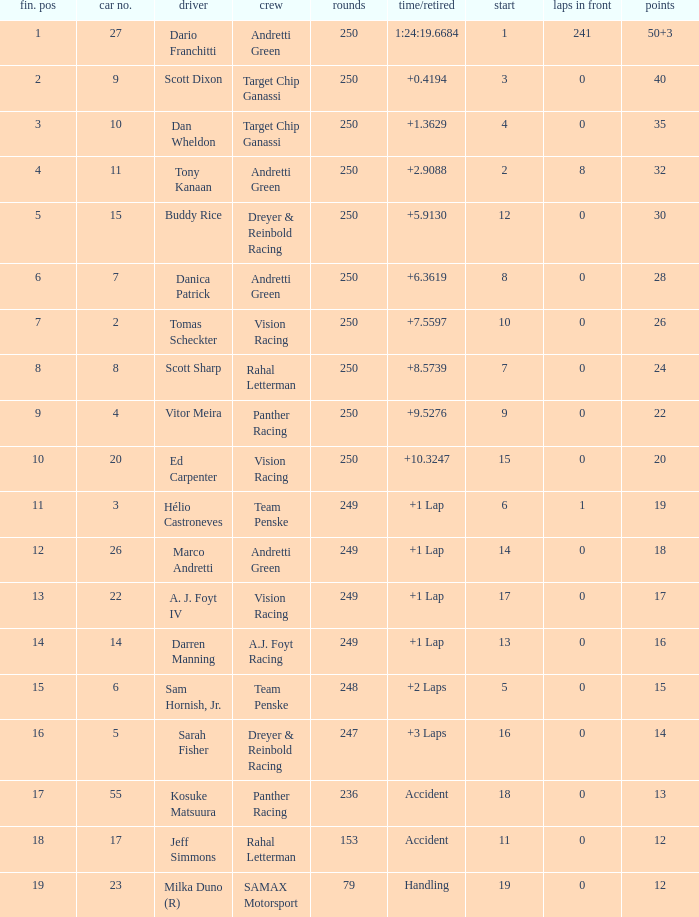Name the number of driver for fin pos of 19 1.0. 